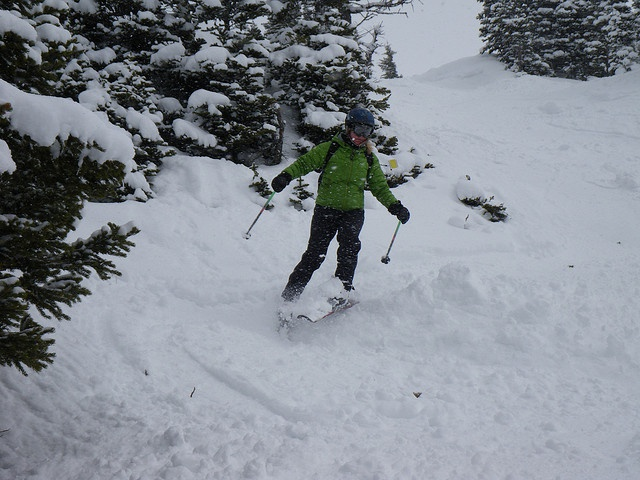Describe the objects in this image and their specific colors. I can see people in black, darkgreen, and gray tones and skis in black, darkgray, and gray tones in this image. 